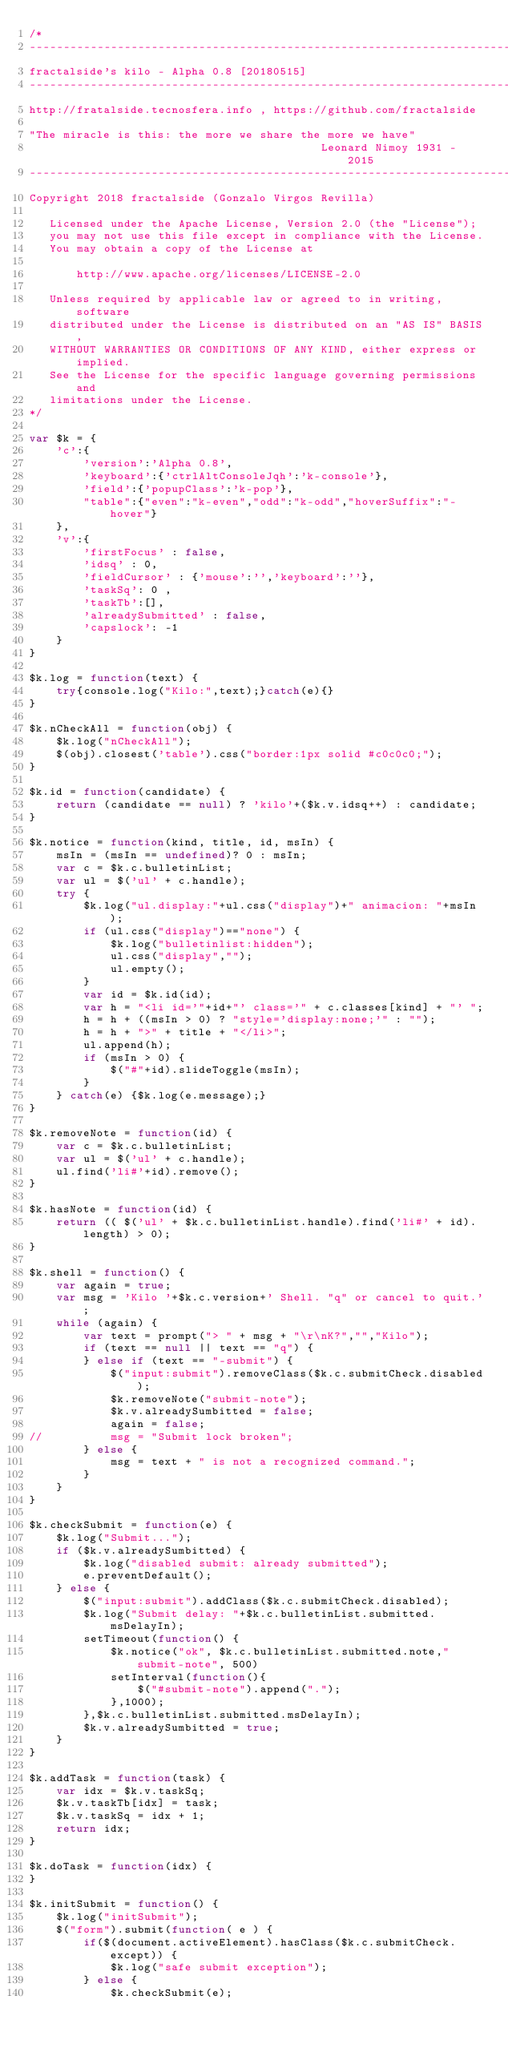<code> <loc_0><loc_0><loc_500><loc_500><_JavaScript_>/*
-------------------------------------------------------------------------
fractalside's kilo - Alpha 0.8 [20180515]
-------------------------------------------------------------------------
http://fratalside.tecnosfera.info , https://github.com/fractalside

"The miracle is this: the more we share the more we have" 
                                           Leonard Nimoy 1931 - 2015
-------------------------------------------------------------------------
Copyright 2018 fractalside (Gonzalo Virgos Revilla)

   Licensed under the Apache License, Version 2.0 (the "License");
   you may not use this file except in compliance with the License.
   You may obtain a copy of the License at

       http://www.apache.org/licenses/LICENSE-2.0

   Unless required by applicable law or agreed to in writing, software
   distributed under the License is distributed on an "AS IS" BASIS,
   WITHOUT WARRANTIES OR CONDITIONS OF ANY KIND, either express or implied.
   See the License for the specific language governing permissions and
   limitations under the License.
*/

var $k = {
	'c':{
		'version':'Alpha 0.8',
		'keyboard':{'ctrlAltConsoleJqh':'k-console'},
		'field':{'popupClass':'k-pop'},
		"table":{"even":"k-even","odd":"k-odd","hoverSuffix":"-hover"}
	},
	'v':{
		'firstFocus' : false, 
		'idsq' : 0,
		'fieldCursor' : {'mouse':'','keyboard':''},
		'taskSq': 0 ,
		'taskTb':[],
		'alreadySubmitted' : false, 
		'capslock': -1
	}
}

$k.log = function(text) {
	try{console.log("Kilo:",text);}catch(e){}
}

$k.nCheckAll = function(obj) {
	$k.log("nCheckAll");
	$(obj).closest('table').css("border:1px solid #c0c0c0;");
}

$k.id = function(candidate) {
	return (candidate == null) ? 'kilo'+($k.v.idsq++) : candidate; 
}

$k.notice = function(kind, title, id, msIn) {
	msIn = (msIn == undefined)? 0 : msIn;
	var c = $k.c.bulletinList;
	var ul = $('ul' + c.handle);
	try { 
		$k.log("ul.display:"+ul.css("display")+" animacion: "+msIn );
		if (ul.css("display")=="none") {
			$k.log("bulletinlist:hidden");
			ul.css("display","");
			ul.empty();
		}
		var id = $k.id(id);
		var h = "<li id='"+id+"' class='" + c.classes[kind] + "' ";
		h = h + ((msIn > 0) ? "style='display:none;'" : "");
		h = h + ">" + title + "</li>";
		ul.append(h);
		if (msIn > 0) {
			$("#"+id).slideToggle(msIn);
		}
	} catch(e) {$k.log(e.message);}
}

$k.removeNote = function(id) {
	var c = $k.c.bulletinList;
	var ul = $('ul' + c.handle);
	ul.find('li#'+id).remove();
}

$k.hasNote = function(id) {
	return (( $('ul' + $k.c.bulletinList.handle).find('li#' + id).length) > 0);
}

$k.shell = function() { 	
	var again = true;
	var msg = 'Kilo '+$k.c.version+' Shell. "q" or cancel to quit.';
	while (again) {
		var text = prompt("> " + msg + "\r\nK?","","Kilo"); 
		if (text == null || text == "q") {
		} else if (text == "-submit") {
			$("input:submit").removeClass($k.c.submitCheck.disabled);
			$k.removeNote("submit-note");
			$k.v.alreadySumbitted = false;
			again = false;
//			msg = "Submit lock broken";
		} else {
			msg = text + " is not a recognized command.";
		}
	}
}

$k.checkSubmit = function(e) {
	$k.log("Submit...");
	if ($k.v.alreadySumbitted) {
		$k.log("disabled submit: already submitted");
		e.preventDefault();
	} else {
		$("input:submit").addClass($k.c.submitCheck.disabled);
		$k.log("Submit delay: "+$k.c.bulletinList.submitted.msDelayIn);
		setTimeout(function() {
			$k.notice("ok", $k.c.bulletinList.submitted.note,"submit-note", 500)
			setInterval(function(){
				$("#submit-note").append(".");
			},1000);
		},$k.c.bulletinList.submitted.msDelayIn);
		$k.v.alreadySumbitted = true;
	}
}

$k.addTask = function(task) {
	var idx = $k.v.taskSq;
	$k.v.taskTb[idx] = task;
	$k.v.taskSq = idx + 1;
	return idx;
}

$k.doTask = function(idx) {
}

$k.initSubmit = function() {
	$k.log("initSubmit");
	$("form").submit(function( e ) {
		if($(document.activeElement).hasClass($k.c.submitCheck.except)) {
			$k.log("safe submit exception");
		} else {
			$k.checkSubmit(e);</code> 